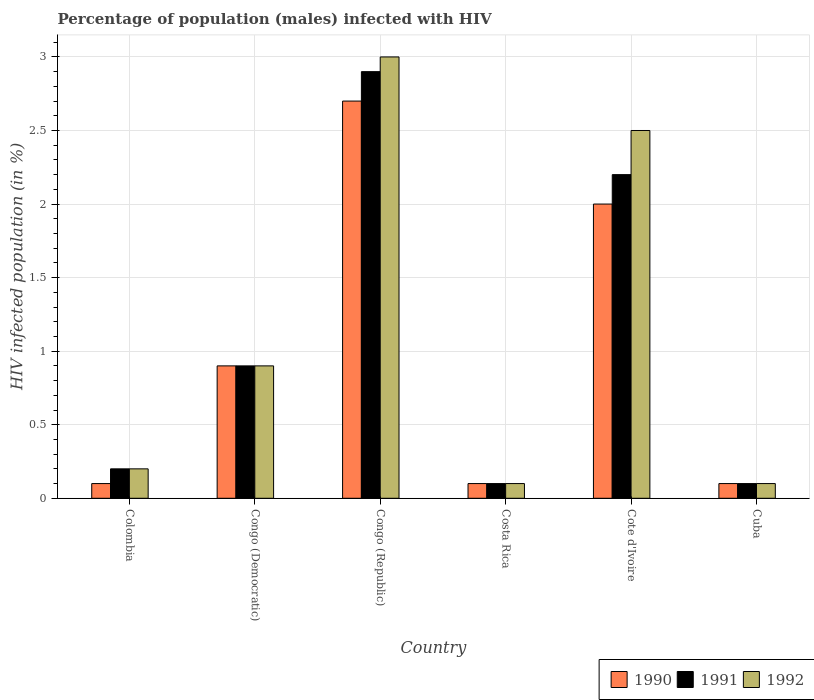How many different coloured bars are there?
Offer a very short reply. 3. Are the number of bars on each tick of the X-axis equal?
Provide a short and direct response. Yes. What is the label of the 2nd group of bars from the left?
Make the answer very short. Congo (Democratic). In how many cases, is the number of bars for a given country not equal to the number of legend labels?
Your answer should be compact. 0. In which country was the percentage of HIV infected male population in 1992 maximum?
Make the answer very short. Congo (Republic). What is the total percentage of HIV infected male population in 1990 in the graph?
Offer a very short reply. 5.9. What is the average percentage of HIV infected male population in 1992 per country?
Give a very brief answer. 1.13. What is the difference between the percentage of HIV infected male population of/in 1991 and percentage of HIV infected male population of/in 1990 in Congo (Republic)?
Provide a short and direct response. 0.2. In how many countries, is the percentage of HIV infected male population in 1991 greater than 0.9 %?
Provide a succinct answer. 2. What is the ratio of the percentage of HIV infected male population in 1990 in Congo (Democratic) to that in Congo (Republic)?
Your answer should be compact. 0.33. Is the percentage of HIV infected male population in 1992 in Congo (Democratic) less than that in Cote d'Ivoire?
Provide a succinct answer. Yes. Is the difference between the percentage of HIV infected male population in 1991 in Colombia and Cote d'Ivoire greater than the difference between the percentage of HIV infected male population in 1990 in Colombia and Cote d'Ivoire?
Make the answer very short. No. What is the difference between the highest and the second highest percentage of HIV infected male population in 1990?
Provide a short and direct response. -1.8. What does the 3rd bar from the left in Costa Rica represents?
Offer a terse response. 1992. What does the 1st bar from the right in Cuba represents?
Offer a very short reply. 1992. Is it the case that in every country, the sum of the percentage of HIV infected male population in 1992 and percentage of HIV infected male population in 1990 is greater than the percentage of HIV infected male population in 1991?
Keep it short and to the point. Yes. What is the difference between two consecutive major ticks on the Y-axis?
Your answer should be compact. 0.5. Are the values on the major ticks of Y-axis written in scientific E-notation?
Offer a very short reply. No. Does the graph contain any zero values?
Offer a very short reply. No. Does the graph contain grids?
Give a very brief answer. Yes. Where does the legend appear in the graph?
Offer a terse response. Bottom right. How are the legend labels stacked?
Your response must be concise. Horizontal. What is the title of the graph?
Provide a short and direct response. Percentage of population (males) infected with HIV. Does "2000" appear as one of the legend labels in the graph?
Make the answer very short. No. What is the label or title of the X-axis?
Make the answer very short. Country. What is the label or title of the Y-axis?
Offer a terse response. HIV infected population (in %). What is the HIV infected population (in %) of 1992 in Colombia?
Offer a very short reply. 0.2. What is the HIV infected population (in %) of 1990 in Congo (Republic)?
Offer a terse response. 2.7. What is the HIV infected population (in %) in 1992 in Costa Rica?
Provide a short and direct response. 0.1. What is the HIV infected population (in %) of 1990 in Cote d'Ivoire?
Your answer should be very brief. 2. What is the HIV infected population (in %) in 1992 in Cote d'Ivoire?
Provide a succinct answer. 2.5. What is the HIV infected population (in %) in 1990 in Cuba?
Your answer should be compact. 0.1. What is the HIV infected population (in %) in 1992 in Cuba?
Offer a very short reply. 0.1. Across all countries, what is the maximum HIV infected population (in %) of 1990?
Offer a very short reply. 2.7. Across all countries, what is the maximum HIV infected population (in %) in 1991?
Your answer should be compact. 2.9. Across all countries, what is the maximum HIV infected population (in %) in 1992?
Your answer should be compact. 3. Across all countries, what is the minimum HIV infected population (in %) in 1991?
Keep it short and to the point. 0.1. What is the difference between the HIV infected population (in %) of 1992 in Colombia and that in Congo (Democratic)?
Give a very brief answer. -0.7. What is the difference between the HIV infected population (in %) in 1990 in Colombia and that in Congo (Republic)?
Ensure brevity in your answer.  -2.6. What is the difference between the HIV infected population (in %) in 1991 in Colombia and that in Congo (Republic)?
Give a very brief answer. -2.7. What is the difference between the HIV infected population (in %) of 1990 in Colombia and that in Costa Rica?
Your answer should be very brief. 0. What is the difference between the HIV infected population (in %) in 1991 in Colombia and that in Cote d'Ivoire?
Your response must be concise. -2. What is the difference between the HIV infected population (in %) in 1990 in Colombia and that in Cuba?
Keep it short and to the point. 0. What is the difference between the HIV infected population (in %) of 1992 in Colombia and that in Cuba?
Give a very brief answer. 0.1. What is the difference between the HIV infected population (in %) of 1991 in Congo (Democratic) and that in Costa Rica?
Keep it short and to the point. 0.8. What is the difference between the HIV infected population (in %) of 1992 in Congo (Democratic) and that in Costa Rica?
Provide a succinct answer. 0.8. What is the difference between the HIV infected population (in %) of 1990 in Congo (Democratic) and that in Cote d'Ivoire?
Ensure brevity in your answer.  -1.1. What is the difference between the HIV infected population (in %) in 1991 in Congo (Democratic) and that in Cote d'Ivoire?
Ensure brevity in your answer.  -1.3. What is the difference between the HIV infected population (in %) in 1992 in Congo (Democratic) and that in Cote d'Ivoire?
Ensure brevity in your answer.  -1.6. What is the difference between the HIV infected population (in %) in 1991 in Congo (Democratic) and that in Cuba?
Offer a very short reply. 0.8. What is the difference between the HIV infected population (in %) in 1992 in Congo (Democratic) and that in Cuba?
Give a very brief answer. 0.8. What is the difference between the HIV infected population (in %) of 1990 in Congo (Republic) and that in Costa Rica?
Your answer should be very brief. 2.6. What is the difference between the HIV infected population (in %) in 1990 in Congo (Republic) and that in Cote d'Ivoire?
Offer a terse response. 0.7. What is the difference between the HIV infected population (in %) in 1991 in Congo (Republic) and that in Cuba?
Provide a succinct answer. 2.8. What is the difference between the HIV infected population (in %) of 1992 in Congo (Republic) and that in Cuba?
Keep it short and to the point. 2.9. What is the difference between the HIV infected population (in %) of 1991 in Costa Rica and that in Cote d'Ivoire?
Your answer should be compact. -2.1. What is the difference between the HIV infected population (in %) in 1992 in Costa Rica and that in Cote d'Ivoire?
Offer a very short reply. -2.4. What is the difference between the HIV infected population (in %) in 1990 in Costa Rica and that in Cuba?
Keep it short and to the point. 0. What is the difference between the HIV infected population (in %) of 1990 in Cote d'Ivoire and that in Cuba?
Offer a terse response. 1.9. What is the difference between the HIV infected population (in %) in 1992 in Cote d'Ivoire and that in Cuba?
Keep it short and to the point. 2.4. What is the difference between the HIV infected population (in %) of 1990 in Colombia and the HIV infected population (in %) of 1991 in Congo (Democratic)?
Your answer should be very brief. -0.8. What is the difference between the HIV infected population (in %) of 1991 in Colombia and the HIV infected population (in %) of 1992 in Congo (Democratic)?
Give a very brief answer. -0.7. What is the difference between the HIV infected population (in %) in 1990 in Colombia and the HIV infected population (in %) in 1991 in Costa Rica?
Offer a very short reply. 0. What is the difference between the HIV infected population (in %) in 1991 in Colombia and the HIV infected population (in %) in 1992 in Costa Rica?
Your response must be concise. 0.1. What is the difference between the HIV infected population (in %) in 1990 in Colombia and the HIV infected population (in %) in 1991 in Cote d'Ivoire?
Ensure brevity in your answer.  -2.1. What is the difference between the HIV infected population (in %) of 1990 in Colombia and the HIV infected population (in %) of 1992 in Cote d'Ivoire?
Make the answer very short. -2.4. What is the difference between the HIV infected population (in %) of 1991 in Colombia and the HIV infected population (in %) of 1992 in Cote d'Ivoire?
Provide a short and direct response. -2.3. What is the difference between the HIV infected population (in %) in 1990 in Colombia and the HIV infected population (in %) in 1991 in Cuba?
Keep it short and to the point. 0. What is the difference between the HIV infected population (in %) of 1990 in Colombia and the HIV infected population (in %) of 1992 in Cuba?
Your answer should be very brief. 0. What is the difference between the HIV infected population (in %) in 1991 in Congo (Democratic) and the HIV infected population (in %) in 1992 in Congo (Republic)?
Offer a very short reply. -2.1. What is the difference between the HIV infected population (in %) of 1990 in Congo (Democratic) and the HIV infected population (in %) of 1991 in Costa Rica?
Ensure brevity in your answer.  0.8. What is the difference between the HIV infected population (in %) of 1991 in Congo (Democratic) and the HIV infected population (in %) of 1992 in Costa Rica?
Keep it short and to the point. 0.8. What is the difference between the HIV infected population (in %) of 1990 in Congo (Democratic) and the HIV infected population (in %) of 1991 in Cote d'Ivoire?
Keep it short and to the point. -1.3. What is the difference between the HIV infected population (in %) in 1991 in Congo (Democratic) and the HIV infected population (in %) in 1992 in Cuba?
Provide a succinct answer. 0.8. What is the difference between the HIV infected population (in %) in 1991 in Congo (Republic) and the HIV infected population (in %) in 1992 in Costa Rica?
Give a very brief answer. 2.8. What is the difference between the HIV infected population (in %) of 1990 in Congo (Republic) and the HIV infected population (in %) of 1991 in Cote d'Ivoire?
Provide a short and direct response. 0.5. What is the difference between the HIV infected population (in %) of 1990 in Congo (Republic) and the HIV infected population (in %) of 1992 in Cote d'Ivoire?
Ensure brevity in your answer.  0.2. What is the difference between the HIV infected population (in %) in 1991 in Congo (Republic) and the HIV infected population (in %) in 1992 in Cote d'Ivoire?
Provide a succinct answer. 0.4. What is the difference between the HIV infected population (in %) of 1990 in Costa Rica and the HIV infected population (in %) of 1991 in Cote d'Ivoire?
Make the answer very short. -2.1. What is the difference between the HIV infected population (in %) of 1990 in Costa Rica and the HIV infected population (in %) of 1992 in Cote d'Ivoire?
Keep it short and to the point. -2.4. What is the difference between the HIV infected population (in %) of 1991 in Costa Rica and the HIV infected population (in %) of 1992 in Cote d'Ivoire?
Ensure brevity in your answer.  -2.4. What is the difference between the HIV infected population (in %) in 1990 in Costa Rica and the HIV infected population (in %) in 1991 in Cuba?
Keep it short and to the point. 0. What is the difference between the HIV infected population (in %) in 1990 in Costa Rica and the HIV infected population (in %) in 1992 in Cuba?
Your answer should be very brief. 0. What is the difference between the HIV infected population (in %) in 1991 in Costa Rica and the HIV infected population (in %) in 1992 in Cuba?
Your response must be concise. 0. What is the difference between the HIV infected population (in %) of 1991 in Cote d'Ivoire and the HIV infected population (in %) of 1992 in Cuba?
Offer a very short reply. 2.1. What is the average HIV infected population (in %) of 1990 per country?
Your answer should be very brief. 0.98. What is the average HIV infected population (in %) in 1991 per country?
Your answer should be compact. 1.07. What is the average HIV infected population (in %) in 1992 per country?
Your response must be concise. 1.13. What is the difference between the HIV infected population (in %) in 1990 and HIV infected population (in %) in 1991 in Colombia?
Your response must be concise. -0.1. What is the difference between the HIV infected population (in %) in 1990 and HIV infected population (in %) in 1992 in Colombia?
Provide a short and direct response. -0.1. What is the difference between the HIV infected population (in %) in 1991 and HIV infected population (in %) in 1992 in Colombia?
Offer a terse response. 0. What is the difference between the HIV infected population (in %) of 1990 and HIV infected population (in %) of 1991 in Congo (Democratic)?
Ensure brevity in your answer.  0. What is the difference between the HIV infected population (in %) in 1990 and HIV infected population (in %) in 1991 in Congo (Republic)?
Your response must be concise. -0.2. What is the difference between the HIV infected population (in %) of 1990 and HIV infected population (in %) of 1991 in Costa Rica?
Provide a succinct answer. 0. What is the difference between the HIV infected population (in %) in 1991 and HIV infected population (in %) in 1992 in Costa Rica?
Keep it short and to the point. 0. What is the difference between the HIV infected population (in %) in 1990 and HIV infected population (in %) in 1991 in Cote d'Ivoire?
Offer a very short reply. -0.2. What is the difference between the HIV infected population (in %) of 1990 and HIV infected population (in %) of 1991 in Cuba?
Your response must be concise. 0. What is the difference between the HIV infected population (in %) in 1990 and HIV infected population (in %) in 1992 in Cuba?
Your answer should be compact. 0. What is the ratio of the HIV infected population (in %) of 1991 in Colombia to that in Congo (Democratic)?
Give a very brief answer. 0.22. What is the ratio of the HIV infected population (in %) in 1992 in Colombia to that in Congo (Democratic)?
Make the answer very short. 0.22. What is the ratio of the HIV infected population (in %) of 1990 in Colombia to that in Congo (Republic)?
Provide a succinct answer. 0.04. What is the ratio of the HIV infected population (in %) in 1991 in Colombia to that in Congo (Republic)?
Offer a very short reply. 0.07. What is the ratio of the HIV infected population (in %) of 1992 in Colombia to that in Congo (Republic)?
Ensure brevity in your answer.  0.07. What is the ratio of the HIV infected population (in %) of 1990 in Colombia to that in Costa Rica?
Provide a succinct answer. 1. What is the ratio of the HIV infected population (in %) in 1992 in Colombia to that in Costa Rica?
Offer a very short reply. 2. What is the ratio of the HIV infected population (in %) in 1991 in Colombia to that in Cote d'Ivoire?
Your response must be concise. 0.09. What is the ratio of the HIV infected population (in %) in 1992 in Colombia to that in Cote d'Ivoire?
Your answer should be compact. 0.08. What is the ratio of the HIV infected population (in %) in 1990 in Colombia to that in Cuba?
Offer a very short reply. 1. What is the ratio of the HIV infected population (in %) in 1992 in Colombia to that in Cuba?
Make the answer very short. 2. What is the ratio of the HIV infected population (in %) of 1991 in Congo (Democratic) to that in Congo (Republic)?
Give a very brief answer. 0.31. What is the ratio of the HIV infected population (in %) in 1992 in Congo (Democratic) to that in Congo (Republic)?
Give a very brief answer. 0.3. What is the ratio of the HIV infected population (in %) in 1990 in Congo (Democratic) to that in Costa Rica?
Ensure brevity in your answer.  9. What is the ratio of the HIV infected population (in %) of 1991 in Congo (Democratic) to that in Costa Rica?
Your answer should be compact. 9. What is the ratio of the HIV infected population (in %) of 1992 in Congo (Democratic) to that in Costa Rica?
Offer a terse response. 9. What is the ratio of the HIV infected population (in %) of 1990 in Congo (Democratic) to that in Cote d'Ivoire?
Ensure brevity in your answer.  0.45. What is the ratio of the HIV infected population (in %) of 1991 in Congo (Democratic) to that in Cote d'Ivoire?
Your response must be concise. 0.41. What is the ratio of the HIV infected population (in %) in 1992 in Congo (Democratic) to that in Cote d'Ivoire?
Keep it short and to the point. 0.36. What is the ratio of the HIV infected population (in %) of 1990 in Congo (Democratic) to that in Cuba?
Ensure brevity in your answer.  9. What is the ratio of the HIV infected population (in %) in 1992 in Congo (Democratic) to that in Cuba?
Make the answer very short. 9. What is the ratio of the HIV infected population (in %) of 1990 in Congo (Republic) to that in Costa Rica?
Offer a terse response. 27. What is the ratio of the HIV infected population (in %) in 1992 in Congo (Republic) to that in Costa Rica?
Keep it short and to the point. 30. What is the ratio of the HIV infected population (in %) of 1990 in Congo (Republic) to that in Cote d'Ivoire?
Keep it short and to the point. 1.35. What is the ratio of the HIV infected population (in %) in 1991 in Congo (Republic) to that in Cote d'Ivoire?
Give a very brief answer. 1.32. What is the ratio of the HIV infected population (in %) of 1992 in Congo (Republic) to that in Cote d'Ivoire?
Provide a short and direct response. 1.2. What is the ratio of the HIV infected population (in %) in 1990 in Congo (Republic) to that in Cuba?
Ensure brevity in your answer.  27. What is the ratio of the HIV infected population (in %) of 1992 in Congo (Republic) to that in Cuba?
Your answer should be compact. 30. What is the ratio of the HIV infected population (in %) of 1990 in Costa Rica to that in Cote d'Ivoire?
Your response must be concise. 0.05. What is the ratio of the HIV infected population (in %) in 1991 in Costa Rica to that in Cote d'Ivoire?
Make the answer very short. 0.05. What is the ratio of the HIV infected population (in %) of 1991 in Costa Rica to that in Cuba?
Offer a terse response. 1. What is the ratio of the HIV infected population (in %) in 1990 in Cote d'Ivoire to that in Cuba?
Give a very brief answer. 20. What is the ratio of the HIV infected population (in %) in 1991 in Cote d'Ivoire to that in Cuba?
Your answer should be very brief. 22. What is the ratio of the HIV infected population (in %) in 1992 in Cote d'Ivoire to that in Cuba?
Provide a short and direct response. 25. What is the difference between the highest and the second highest HIV infected population (in %) in 1991?
Provide a short and direct response. 0.7. What is the difference between the highest and the second highest HIV infected population (in %) in 1992?
Provide a succinct answer. 0.5. What is the difference between the highest and the lowest HIV infected population (in %) in 1991?
Give a very brief answer. 2.8. What is the difference between the highest and the lowest HIV infected population (in %) of 1992?
Ensure brevity in your answer.  2.9. 